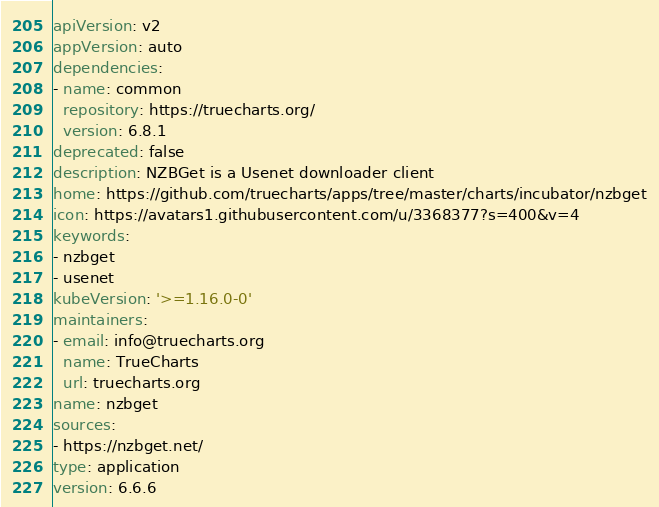<code> <loc_0><loc_0><loc_500><loc_500><_YAML_>apiVersion: v2
appVersion: auto
dependencies:
- name: common
  repository: https://truecharts.org/
  version: 6.8.1
deprecated: false
description: NZBGet is a Usenet downloader client
home: https://github.com/truecharts/apps/tree/master/charts/incubator/nzbget
icon: https://avatars1.githubusercontent.com/u/3368377?s=400&v=4
keywords:
- nzbget
- usenet
kubeVersion: '>=1.16.0-0'
maintainers:
- email: info@truecharts.org
  name: TrueCharts
  url: truecharts.org
name: nzbget
sources:
- https://nzbget.net/
type: application
version: 6.6.6
</code> 